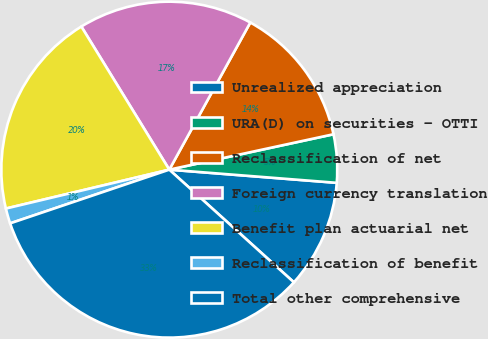Convert chart. <chart><loc_0><loc_0><loc_500><loc_500><pie_chart><fcel>Unrealized appreciation<fcel>URA(D) on securities - OTTI<fcel>Reclassification of net<fcel>Foreign currency translation<fcel>Benefit plan actuarial net<fcel>Reclassification of benefit<fcel>Total other comprehensive<nl><fcel>10.45%<fcel>4.63%<fcel>13.61%<fcel>16.78%<fcel>19.95%<fcel>1.46%<fcel>33.12%<nl></chart> 